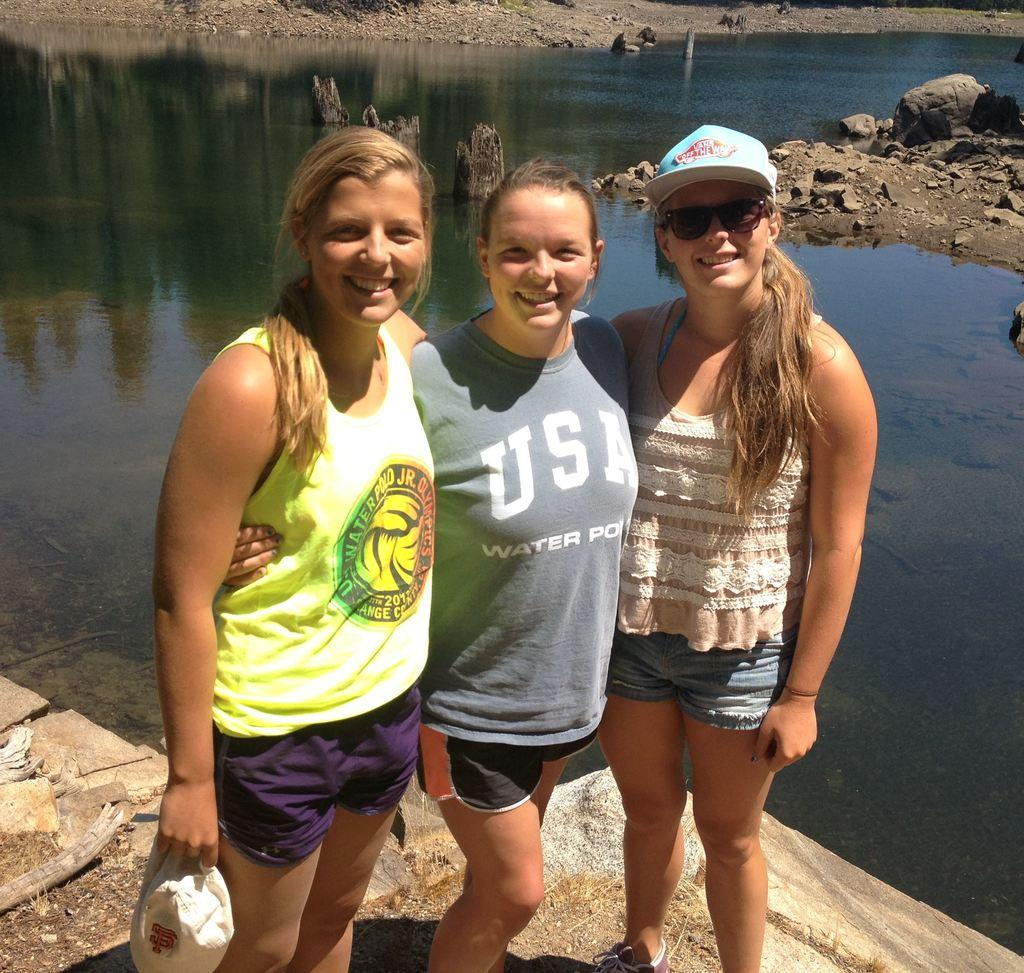How many people are in the image? There are three people standing in the center of the image. What are the people doing in the image? The people are smiling. What can be seen in the background of the image? There is a river and rocks in the background of the image. What time of day is it in the image, considering it's a night scene? The image does not depict a night scene; it is a daytime image with people smiling and a river in the background. 